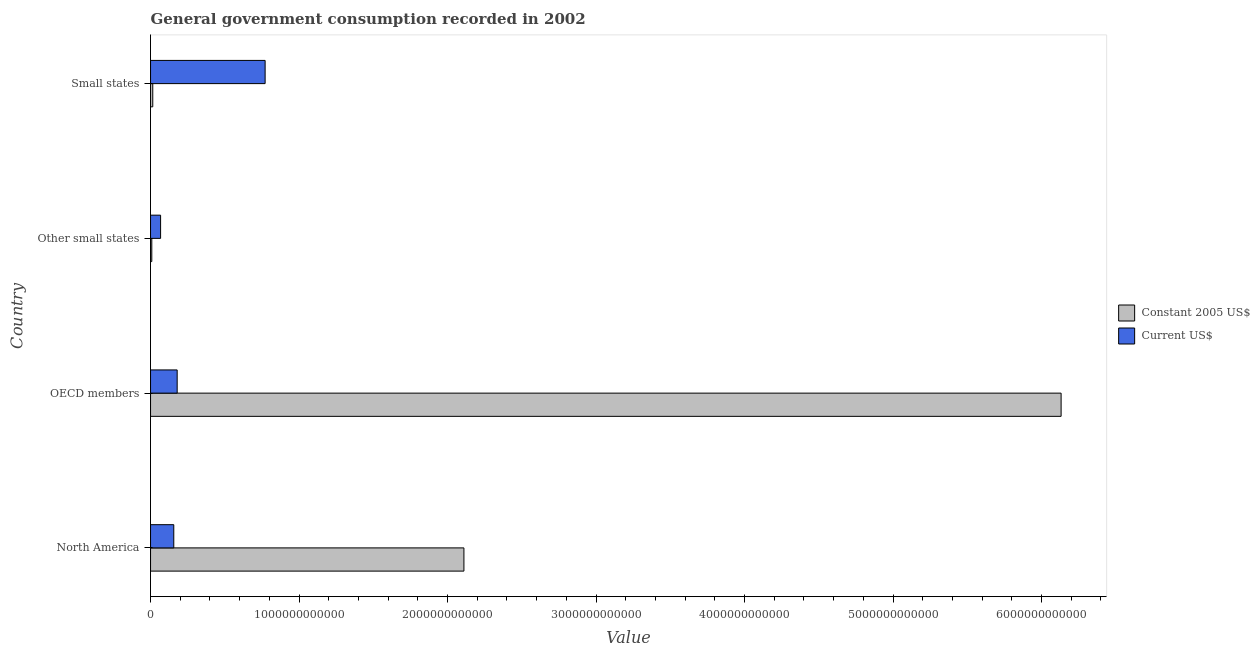How many different coloured bars are there?
Your answer should be very brief. 2. How many groups of bars are there?
Keep it short and to the point. 4. Are the number of bars per tick equal to the number of legend labels?
Keep it short and to the point. Yes. Are the number of bars on each tick of the Y-axis equal?
Offer a terse response. Yes. How many bars are there on the 2nd tick from the bottom?
Your answer should be very brief. 2. What is the label of the 1st group of bars from the top?
Keep it short and to the point. Small states. What is the value consumed in constant 2005 us$ in North America?
Make the answer very short. 2.11e+12. Across all countries, what is the maximum value consumed in constant 2005 us$?
Give a very brief answer. 6.13e+12. Across all countries, what is the minimum value consumed in constant 2005 us$?
Your answer should be very brief. 8.52e+09. In which country was the value consumed in constant 2005 us$ maximum?
Ensure brevity in your answer.  OECD members. In which country was the value consumed in constant 2005 us$ minimum?
Offer a terse response. Other small states. What is the total value consumed in current us$ in the graph?
Your answer should be compact. 1.18e+12. What is the difference between the value consumed in current us$ in North America and that in Small states?
Provide a short and direct response. -6.15e+11. What is the difference between the value consumed in current us$ in Small states and the value consumed in constant 2005 us$ in North America?
Offer a very short reply. -1.34e+12. What is the average value consumed in current us$ per country?
Provide a short and direct response. 2.94e+11. What is the difference between the value consumed in constant 2005 us$ and value consumed in current us$ in OECD members?
Your response must be concise. 5.95e+12. In how many countries, is the value consumed in constant 2005 us$ greater than 4600000000000 ?
Your answer should be compact. 1. What is the ratio of the value consumed in constant 2005 us$ in North America to that in Other small states?
Give a very brief answer. 247.75. Is the difference between the value consumed in current us$ in OECD members and Other small states greater than the difference between the value consumed in constant 2005 us$ in OECD members and Other small states?
Keep it short and to the point. No. What is the difference between the highest and the second highest value consumed in constant 2005 us$?
Your response must be concise. 4.02e+12. What is the difference between the highest and the lowest value consumed in current us$?
Offer a terse response. 7.04e+11. What does the 1st bar from the top in North America represents?
Give a very brief answer. Current US$. What does the 1st bar from the bottom in Small states represents?
Provide a succinct answer. Constant 2005 US$. Are all the bars in the graph horizontal?
Your answer should be compact. Yes. How many countries are there in the graph?
Give a very brief answer. 4. What is the difference between two consecutive major ticks on the X-axis?
Keep it short and to the point. 1.00e+12. Are the values on the major ticks of X-axis written in scientific E-notation?
Your answer should be compact. No. Where does the legend appear in the graph?
Keep it short and to the point. Center right. How many legend labels are there?
Give a very brief answer. 2. What is the title of the graph?
Give a very brief answer. General government consumption recorded in 2002. Does "Crop" appear as one of the legend labels in the graph?
Provide a succinct answer. No. What is the label or title of the X-axis?
Your answer should be compact. Value. What is the Value of Constant 2005 US$ in North America?
Provide a short and direct response. 2.11e+12. What is the Value in Current US$ in North America?
Make the answer very short. 1.57e+11. What is the Value of Constant 2005 US$ in OECD members?
Ensure brevity in your answer.  6.13e+12. What is the Value of Current US$ in OECD members?
Provide a succinct answer. 1.79e+11. What is the Value in Constant 2005 US$ in Other small states?
Make the answer very short. 8.52e+09. What is the Value of Current US$ in Other small states?
Provide a succinct answer. 6.77e+1. What is the Value of Constant 2005 US$ in Small states?
Make the answer very short. 1.50e+1. What is the Value in Current US$ in Small states?
Your answer should be very brief. 7.72e+11. Across all countries, what is the maximum Value of Constant 2005 US$?
Offer a very short reply. 6.13e+12. Across all countries, what is the maximum Value in Current US$?
Provide a short and direct response. 7.72e+11. Across all countries, what is the minimum Value of Constant 2005 US$?
Your response must be concise. 8.52e+09. Across all countries, what is the minimum Value of Current US$?
Your answer should be compact. 6.77e+1. What is the total Value of Constant 2005 US$ in the graph?
Offer a very short reply. 8.27e+12. What is the total Value of Current US$ in the graph?
Provide a short and direct response. 1.18e+12. What is the difference between the Value in Constant 2005 US$ in North America and that in OECD members?
Your answer should be compact. -4.02e+12. What is the difference between the Value of Current US$ in North America and that in OECD members?
Keep it short and to the point. -2.28e+1. What is the difference between the Value of Constant 2005 US$ in North America and that in Other small states?
Provide a succinct answer. 2.10e+12. What is the difference between the Value of Current US$ in North America and that in Other small states?
Provide a short and direct response. 8.88e+1. What is the difference between the Value of Constant 2005 US$ in North America and that in Small states?
Provide a succinct answer. 2.10e+12. What is the difference between the Value in Current US$ in North America and that in Small states?
Your answer should be very brief. -6.15e+11. What is the difference between the Value in Constant 2005 US$ in OECD members and that in Other small states?
Offer a terse response. 6.12e+12. What is the difference between the Value in Current US$ in OECD members and that in Other small states?
Give a very brief answer. 1.12e+11. What is the difference between the Value of Constant 2005 US$ in OECD members and that in Small states?
Offer a very short reply. 6.12e+12. What is the difference between the Value in Current US$ in OECD members and that in Small states?
Offer a very short reply. -5.92e+11. What is the difference between the Value in Constant 2005 US$ in Other small states and that in Small states?
Provide a short and direct response. -6.51e+09. What is the difference between the Value in Current US$ in Other small states and that in Small states?
Your answer should be compact. -7.04e+11. What is the difference between the Value in Constant 2005 US$ in North America and the Value in Current US$ in OECD members?
Provide a succinct answer. 1.93e+12. What is the difference between the Value of Constant 2005 US$ in North America and the Value of Current US$ in Other small states?
Ensure brevity in your answer.  2.04e+12. What is the difference between the Value of Constant 2005 US$ in North America and the Value of Current US$ in Small states?
Offer a very short reply. 1.34e+12. What is the difference between the Value in Constant 2005 US$ in OECD members and the Value in Current US$ in Other small states?
Your answer should be very brief. 6.06e+12. What is the difference between the Value in Constant 2005 US$ in OECD members and the Value in Current US$ in Small states?
Provide a succinct answer. 5.36e+12. What is the difference between the Value of Constant 2005 US$ in Other small states and the Value of Current US$ in Small states?
Provide a short and direct response. -7.63e+11. What is the average Value in Constant 2005 US$ per country?
Your response must be concise. 2.07e+12. What is the average Value in Current US$ per country?
Your response must be concise. 2.94e+11. What is the difference between the Value in Constant 2005 US$ and Value in Current US$ in North America?
Make the answer very short. 1.95e+12. What is the difference between the Value of Constant 2005 US$ and Value of Current US$ in OECD members?
Keep it short and to the point. 5.95e+12. What is the difference between the Value in Constant 2005 US$ and Value in Current US$ in Other small states?
Your answer should be very brief. -5.92e+1. What is the difference between the Value of Constant 2005 US$ and Value of Current US$ in Small states?
Your response must be concise. -7.57e+11. What is the ratio of the Value in Constant 2005 US$ in North America to that in OECD members?
Offer a very short reply. 0.34. What is the ratio of the Value of Current US$ in North America to that in OECD members?
Give a very brief answer. 0.87. What is the ratio of the Value of Constant 2005 US$ in North America to that in Other small states?
Give a very brief answer. 247.75. What is the ratio of the Value of Current US$ in North America to that in Other small states?
Offer a very short reply. 2.31. What is the ratio of the Value in Constant 2005 US$ in North America to that in Small states?
Make the answer very short. 140.45. What is the ratio of the Value in Current US$ in North America to that in Small states?
Make the answer very short. 0.2. What is the ratio of the Value in Constant 2005 US$ in OECD members to that in Other small states?
Make the answer very short. 719.87. What is the ratio of the Value in Current US$ in OECD members to that in Other small states?
Your response must be concise. 2.65. What is the ratio of the Value of Constant 2005 US$ in OECD members to that in Small states?
Your answer should be very brief. 408.1. What is the ratio of the Value of Current US$ in OECD members to that in Small states?
Offer a very short reply. 0.23. What is the ratio of the Value of Constant 2005 US$ in Other small states to that in Small states?
Keep it short and to the point. 0.57. What is the ratio of the Value of Current US$ in Other small states to that in Small states?
Your response must be concise. 0.09. What is the difference between the highest and the second highest Value of Constant 2005 US$?
Make the answer very short. 4.02e+12. What is the difference between the highest and the second highest Value in Current US$?
Keep it short and to the point. 5.92e+11. What is the difference between the highest and the lowest Value of Constant 2005 US$?
Ensure brevity in your answer.  6.12e+12. What is the difference between the highest and the lowest Value in Current US$?
Keep it short and to the point. 7.04e+11. 